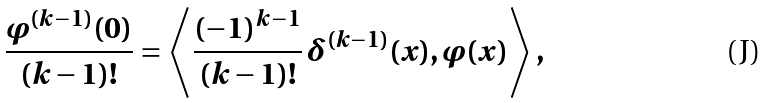Convert formula to latex. <formula><loc_0><loc_0><loc_500><loc_500>\frac { \varphi ^ { ( k - 1 ) } ( 0 ) } { ( k - 1 ) ! } = \left \langle \frac { ( - 1 ) ^ { k - 1 } } { ( k - 1 ) ! } \, \delta ^ { ( k - 1 ) } ( x ) , \varphi ( x ) \right \rangle ,</formula> 